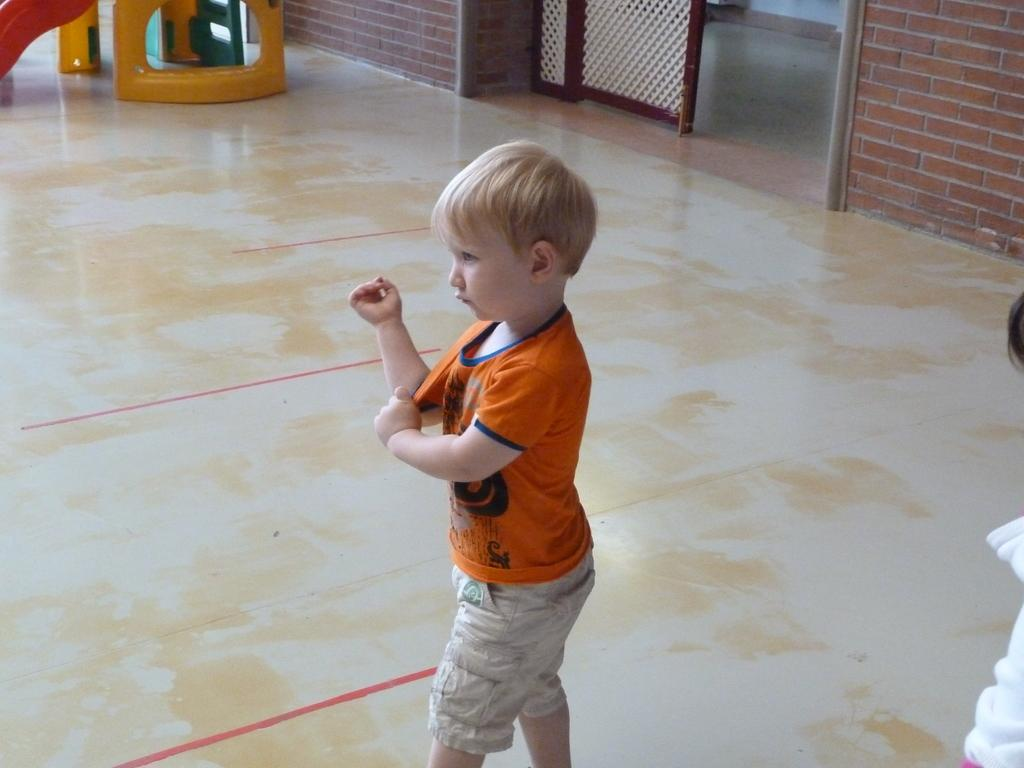What is the main subject of the image? The main subject of the image is a boy. Where is the boy standing in the image? The boy is standing on the floor. What can be seen in the background of the image? There is a door in the background of the image. What is present in the top right corner of the image? There is a wall in the right side top corner of the image. What type of berry is being discussed by the committee in the image? There is no committee or berry present in the image; it features a boy standing on the floor with a door and a wall in the background. 